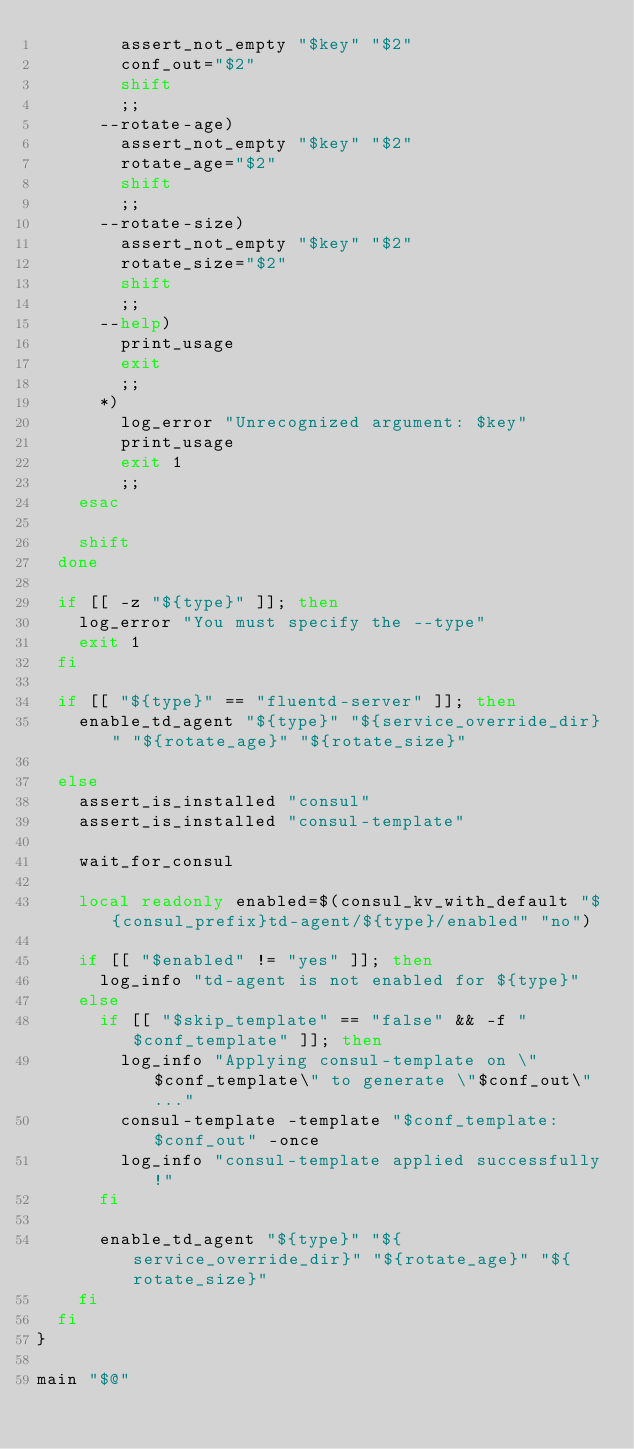Convert code to text. <code><loc_0><loc_0><loc_500><loc_500><_Bash_>        assert_not_empty "$key" "$2"
        conf_out="$2"
        shift
        ;;
      --rotate-age)
        assert_not_empty "$key" "$2"
        rotate_age="$2"
        shift
        ;;
      --rotate-size)
        assert_not_empty "$key" "$2"
        rotate_size="$2"
        shift
        ;;
      --help)
        print_usage
        exit
        ;;
      *)
        log_error "Unrecognized argument: $key"
        print_usage
        exit 1
        ;;
    esac

    shift
  done

  if [[ -z "${type}" ]]; then
    log_error "You must specify the --type"
    exit 1
  fi

  if [[ "${type}" == "fluentd-server" ]]; then
    enable_td_agent "${type}" "${service_override_dir}" "${rotate_age}" "${rotate_size}"
  
  else 
    assert_is_installed "consul"
    assert_is_installed "consul-template"

    wait_for_consul

    local readonly enabled=$(consul_kv_with_default "${consul_prefix}td-agent/${type}/enabled" "no")

    if [[ "$enabled" != "yes" ]]; then
      log_info "td-agent is not enabled for ${type}"
    else
      if [[ "$skip_template" == "false" && -f "$conf_template" ]]; then
        log_info "Applying consul-template on \"$conf_template\" to generate \"$conf_out\"..."
        consul-template -template "$conf_template:$conf_out" -once
        log_info "consul-template applied successfully!"
      fi

      enable_td_agent "${type}" "${service_override_dir}" "${rotate_age}" "${rotate_size}"
    fi
  fi
}

main "$@"
</code> 